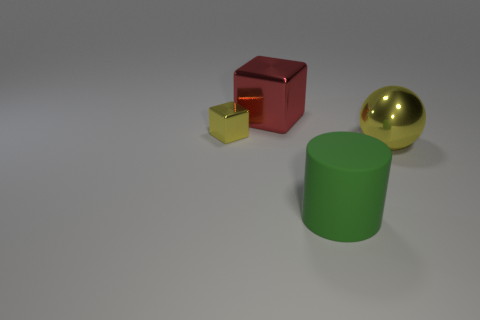Add 1 large metallic blocks. How many objects exist? 5 Subtract all balls. How many objects are left? 3 Add 4 small purple cylinders. How many small purple cylinders exist? 4 Subtract 0 blue spheres. How many objects are left? 4 Subtract all green spheres. Subtract all large red objects. How many objects are left? 3 Add 2 big red shiny blocks. How many big red shiny blocks are left? 3 